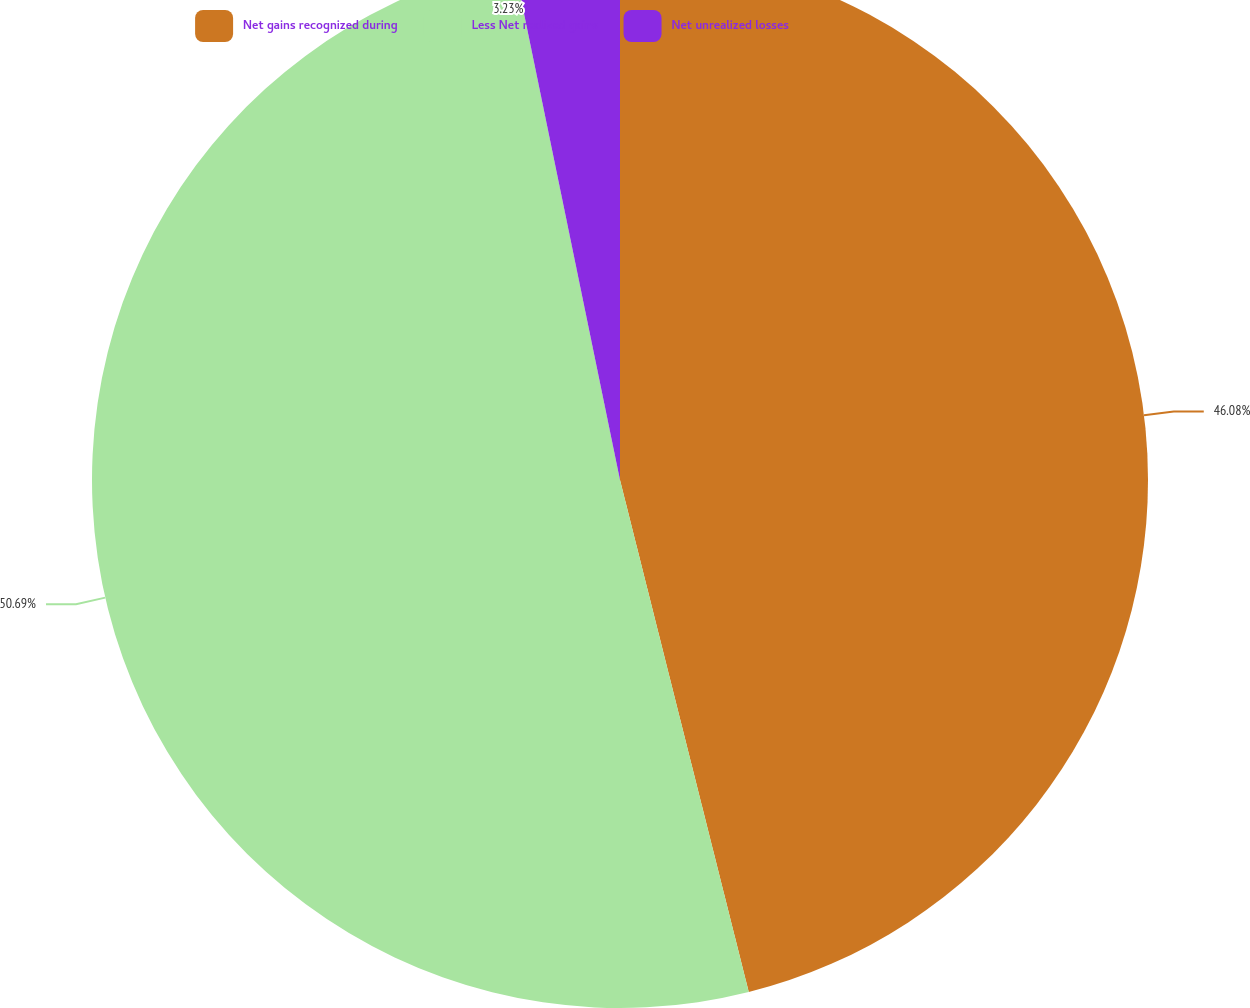Convert chart. <chart><loc_0><loc_0><loc_500><loc_500><pie_chart><fcel>Net gains recognized during<fcel>Less Net realized gains<fcel>Net unrealized losses<nl><fcel>46.08%<fcel>50.69%<fcel>3.23%<nl></chart> 